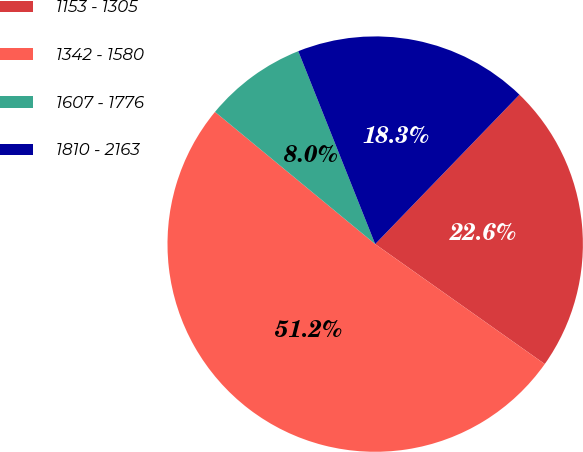Convert chart to OTSL. <chart><loc_0><loc_0><loc_500><loc_500><pie_chart><fcel>1153 - 1305<fcel>1342 - 1580<fcel>1607 - 1776<fcel>1810 - 2163<nl><fcel>22.58%<fcel>51.19%<fcel>7.98%<fcel>18.26%<nl></chart> 